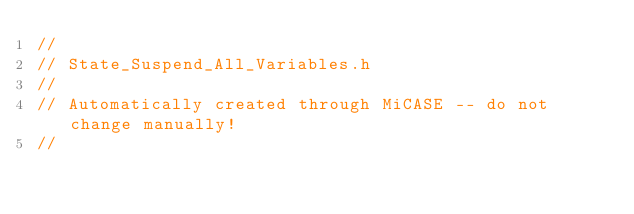Convert code to text. <code><loc_0><loc_0><loc_500><loc_500><_C_>//
// State_Suspend_All_Variables.h
//
// Automatically created through MiCASE -- do not change manually!
//
</code> 